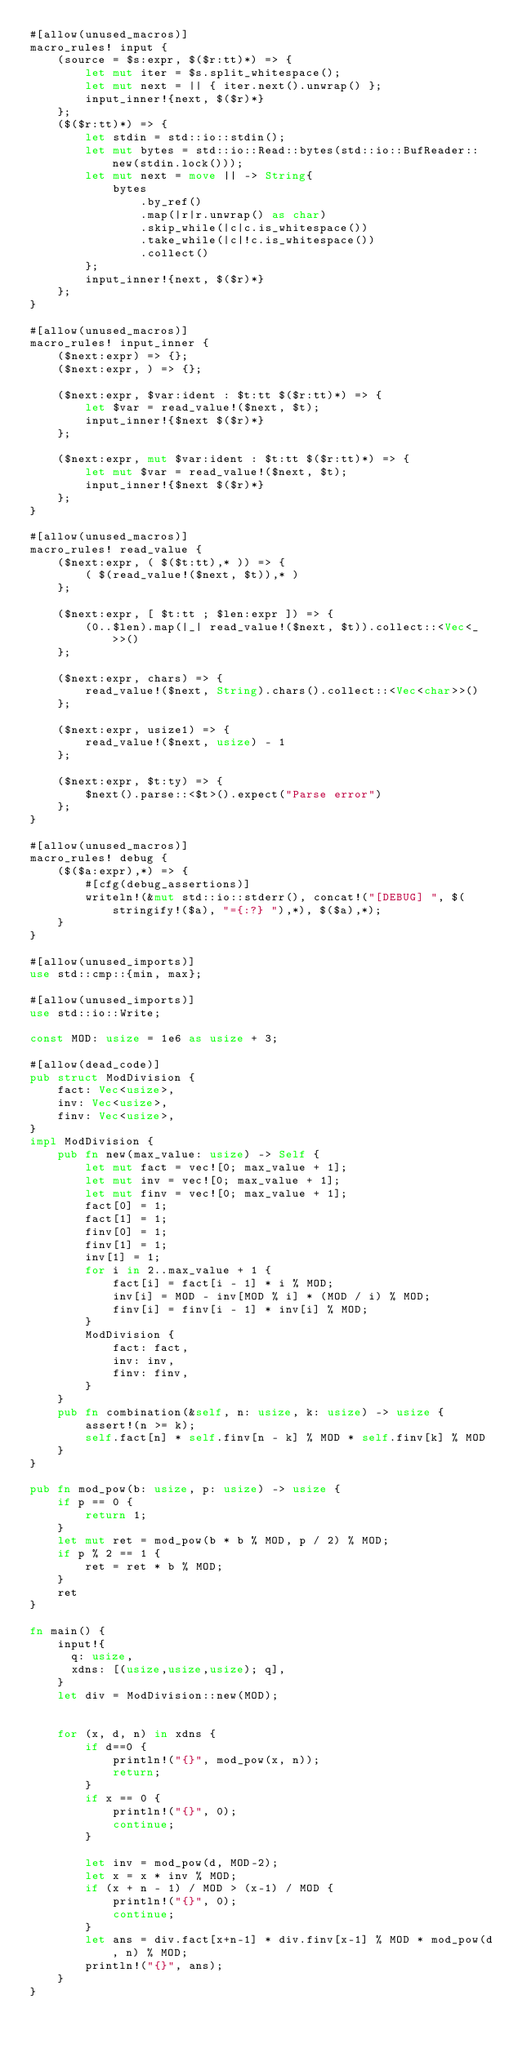Convert code to text. <code><loc_0><loc_0><loc_500><loc_500><_Rust_>#[allow(unused_macros)]
macro_rules! input {
    (source = $s:expr, $($r:tt)*) => {
        let mut iter = $s.split_whitespace();
        let mut next = || { iter.next().unwrap() };
        input_inner!{next, $($r)*}
    };
    ($($r:tt)*) => {
        let stdin = std::io::stdin();
        let mut bytes = std::io::Read::bytes(std::io::BufReader::new(stdin.lock()));
        let mut next = move || -> String{
            bytes
                .by_ref()
                .map(|r|r.unwrap() as char)
                .skip_while(|c|c.is_whitespace())
                .take_while(|c|!c.is_whitespace())
                .collect()
        };
        input_inner!{next, $($r)*}
    };
}

#[allow(unused_macros)]
macro_rules! input_inner {
    ($next:expr) => {};
    ($next:expr, ) => {};

    ($next:expr, $var:ident : $t:tt $($r:tt)*) => {
        let $var = read_value!($next, $t);
        input_inner!{$next $($r)*}
    };

    ($next:expr, mut $var:ident : $t:tt $($r:tt)*) => {
        let mut $var = read_value!($next, $t);
        input_inner!{$next $($r)*}
    };
}

#[allow(unused_macros)]
macro_rules! read_value {
    ($next:expr, ( $($t:tt),* )) => {
        ( $(read_value!($next, $t)),* )
    };

    ($next:expr, [ $t:tt ; $len:expr ]) => {
        (0..$len).map(|_| read_value!($next, $t)).collect::<Vec<_>>()
    };

    ($next:expr, chars) => {
        read_value!($next, String).chars().collect::<Vec<char>>()
    };

    ($next:expr, usize1) => {
        read_value!($next, usize) - 1
    };

    ($next:expr, $t:ty) => {
        $next().parse::<$t>().expect("Parse error")
    };
}

#[allow(unused_macros)]
macro_rules! debug {
    ($($a:expr),*) => {
        #[cfg(debug_assertions)]
        writeln!(&mut std::io::stderr(), concat!("[DEBUG] ", $(stringify!($a), "={:?} "),*), $($a),*);
    }
}

#[allow(unused_imports)]
use std::cmp::{min, max};

#[allow(unused_imports)]
use std::io::Write;

const MOD: usize = 1e6 as usize + 3;

#[allow(dead_code)]
pub struct ModDivision {
    fact: Vec<usize>,
    inv: Vec<usize>,
    finv: Vec<usize>,
}
impl ModDivision {
    pub fn new(max_value: usize) -> Self {
        let mut fact = vec![0; max_value + 1];
        let mut inv = vec![0; max_value + 1];
        let mut finv = vec![0; max_value + 1];
        fact[0] = 1;
        fact[1] = 1;
        finv[0] = 1;
        finv[1] = 1;
        inv[1] = 1;
        for i in 2..max_value + 1 {
            fact[i] = fact[i - 1] * i % MOD;
            inv[i] = MOD - inv[MOD % i] * (MOD / i) % MOD;
            finv[i] = finv[i - 1] * inv[i] % MOD;
        }
        ModDivision {
            fact: fact,
            inv: inv,
            finv: finv,
        }
    }
    pub fn combination(&self, n: usize, k: usize) -> usize {
        assert!(n >= k);
        self.fact[n] * self.finv[n - k] % MOD * self.finv[k] % MOD
    }
}

pub fn mod_pow(b: usize, p: usize) -> usize {
    if p == 0 {
        return 1;
    }
    let mut ret = mod_pow(b * b % MOD, p / 2) % MOD;
    if p % 2 == 1 {
        ret = ret * b % MOD;
    }
    ret
}

fn main() {
    input!{
      q: usize,
      xdns: [(usize,usize,usize); q],
    }
    let div = ModDivision::new(MOD);


    for (x, d, n) in xdns {
        if d==0 {
            println!("{}", mod_pow(x, n));
            return;
        }
        if x == 0 {
            println!("{}", 0);
            continue;
        }

        let inv = mod_pow(d, MOD-2);
        let x = x * inv % MOD;
        if (x + n - 1) / MOD > (x-1) / MOD {
            println!("{}", 0);
            continue;
        }
        let ans = div.fact[x+n-1] * div.finv[x-1] % MOD * mod_pow(d, n) % MOD;
        println!("{}", ans);
    }
}
</code> 